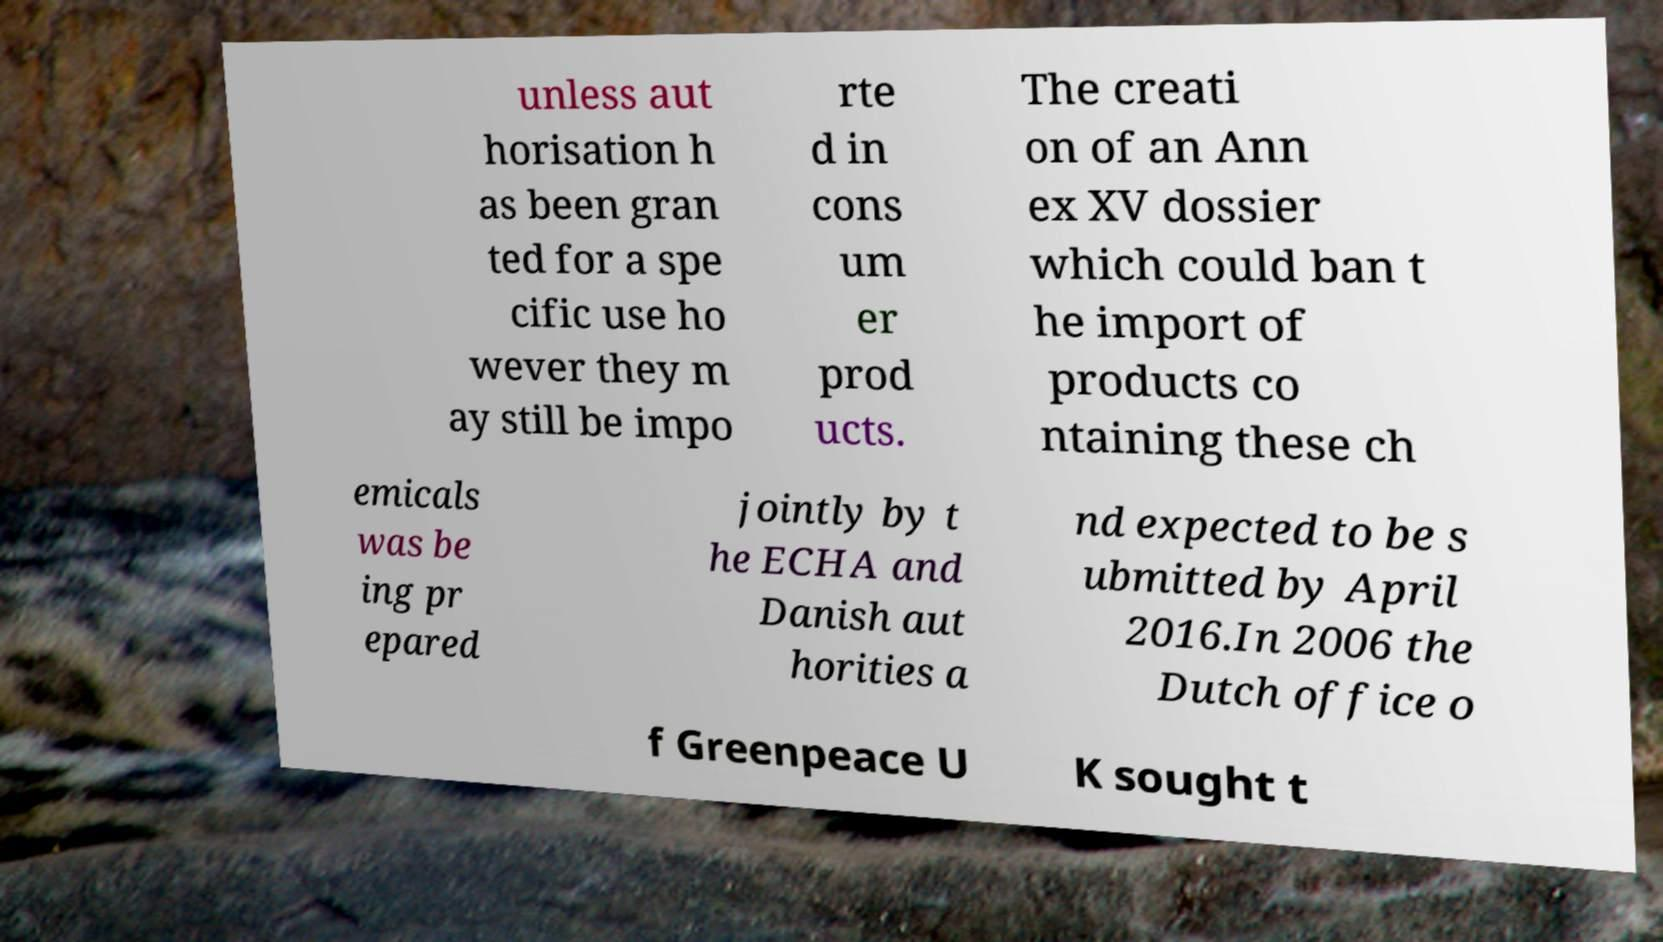Can you read and provide the text displayed in the image?This photo seems to have some interesting text. Can you extract and type it out for me? unless aut horisation h as been gran ted for a spe cific use ho wever they m ay still be impo rte d in cons um er prod ucts. The creati on of an Ann ex XV dossier which could ban t he import of products co ntaining these ch emicals was be ing pr epared jointly by t he ECHA and Danish aut horities a nd expected to be s ubmitted by April 2016.In 2006 the Dutch office o f Greenpeace U K sought t 